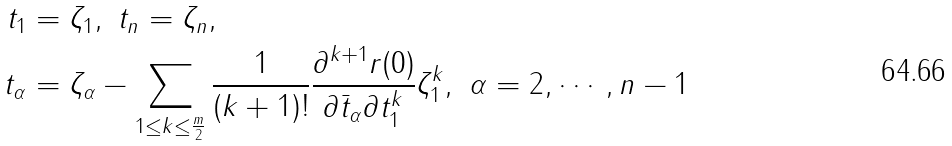Convert formula to latex. <formula><loc_0><loc_0><loc_500><loc_500>t _ { 1 } & = \zeta _ { 1 } , \ t _ { n } = \zeta _ { n } , \\ t _ { \alpha } & = \zeta _ { \alpha } - \sum _ { 1 \leq k \leq \frac { m } { 2 } } \frac { 1 } { ( k + 1 ) ! } \frac { \partial ^ { k + 1 } r ( 0 ) } { \partial \bar { t } _ { \alpha } \partial t _ { 1 } ^ { k } } \zeta _ { 1 } ^ { k } , \ \alpha = 2 , \cdots , n - 1</formula> 